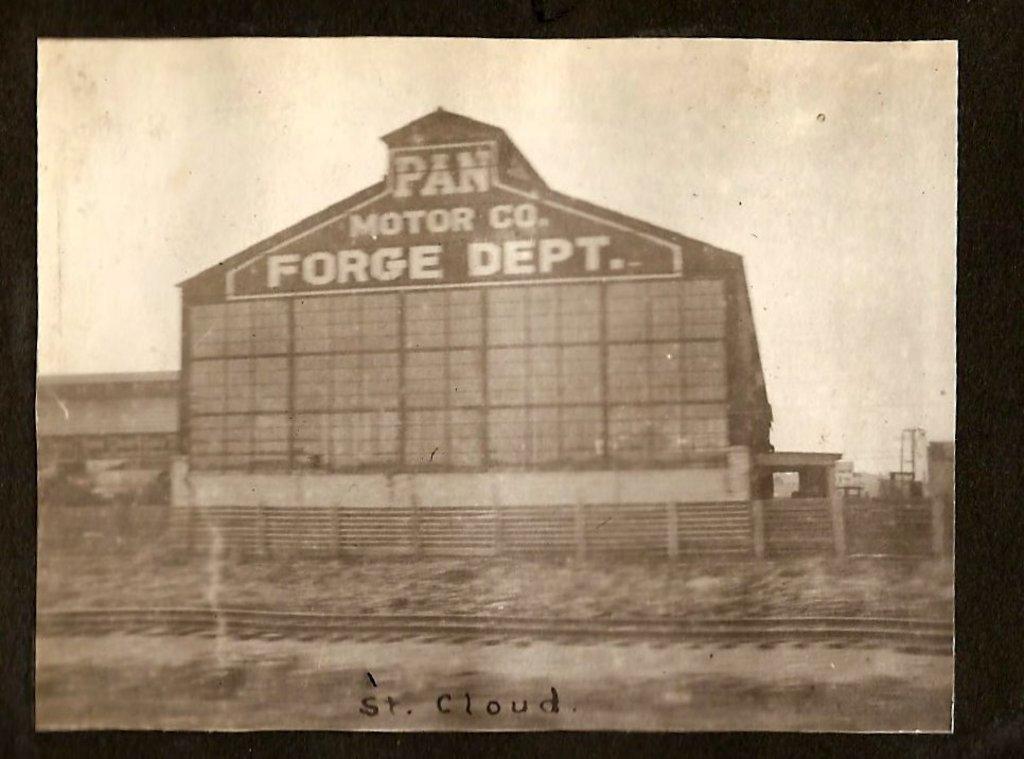Could you give a brief overview of what you see in this image? In this image we can see photo of a building with name. Near to the building there is railway track. In the background there is sky. 